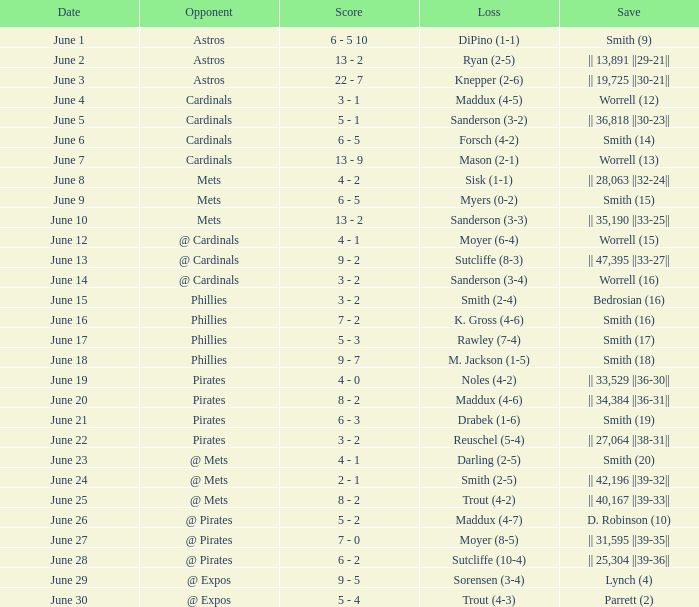What is the date for the game that included a loss of sutcliffe (10-4)? June 28. 